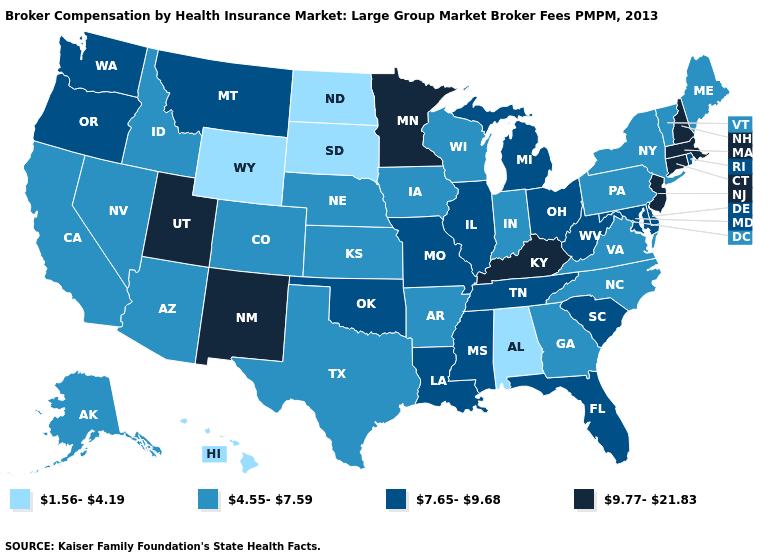What is the lowest value in states that border Texas?
Quick response, please. 4.55-7.59. Among the states that border Nevada , which have the highest value?
Be succinct. Utah. Is the legend a continuous bar?
Be succinct. No. Name the states that have a value in the range 1.56-4.19?
Concise answer only. Alabama, Hawaii, North Dakota, South Dakota, Wyoming. Name the states that have a value in the range 1.56-4.19?
Be succinct. Alabama, Hawaii, North Dakota, South Dakota, Wyoming. Does West Virginia have a higher value than Minnesota?
Give a very brief answer. No. Which states have the highest value in the USA?
Give a very brief answer. Connecticut, Kentucky, Massachusetts, Minnesota, New Hampshire, New Jersey, New Mexico, Utah. What is the value of Illinois?
Keep it brief. 7.65-9.68. What is the value of Virginia?
Short answer required. 4.55-7.59. Does New Hampshire have the lowest value in the Northeast?
Write a very short answer. No. How many symbols are there in the legend?
Concise answer only. 4. What is the value of Oregon?
Write a very short answer. 7.65-9.68. Name the states that have a value in the range 7.65-9.68?
Write a very short answer. Delaware, Florida, Illinois, Louisiana, Maryland, Michigan, Mississippi, Missouri, Montana, Ohio, Oklahoma, Oregon, Rhode Island, South Carolina, Tennessee, Washington, West Virginia. Name the states that have a value in the range 1.56-4.19?
Keep it brief. Alabama, Hawaii, North Dakota, South Dakota, Wyoming. Name the states that have a value in the range 9.77-21.83?
Keep it brief. Connecticut, Kentucky, Massachusetts, Minnesota, New Hampshire, New Jersey, New Mexico, Utah. 